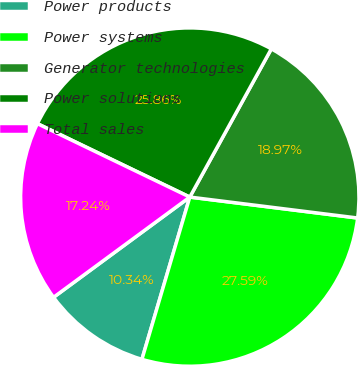Convert chart to OTSL. <chart><loc_0><loc_0><loc_500><loc_500><pie_chart><fcel>Power products<fcel>Power systems<fcel>Generator technologies<fcel>Power solutions<fcel>Total sales<nl><fcel>10.34%<fcel>27.59%<fcel>18.97%<fcel>25.86%<fcel>17.24%<nl></chart> 